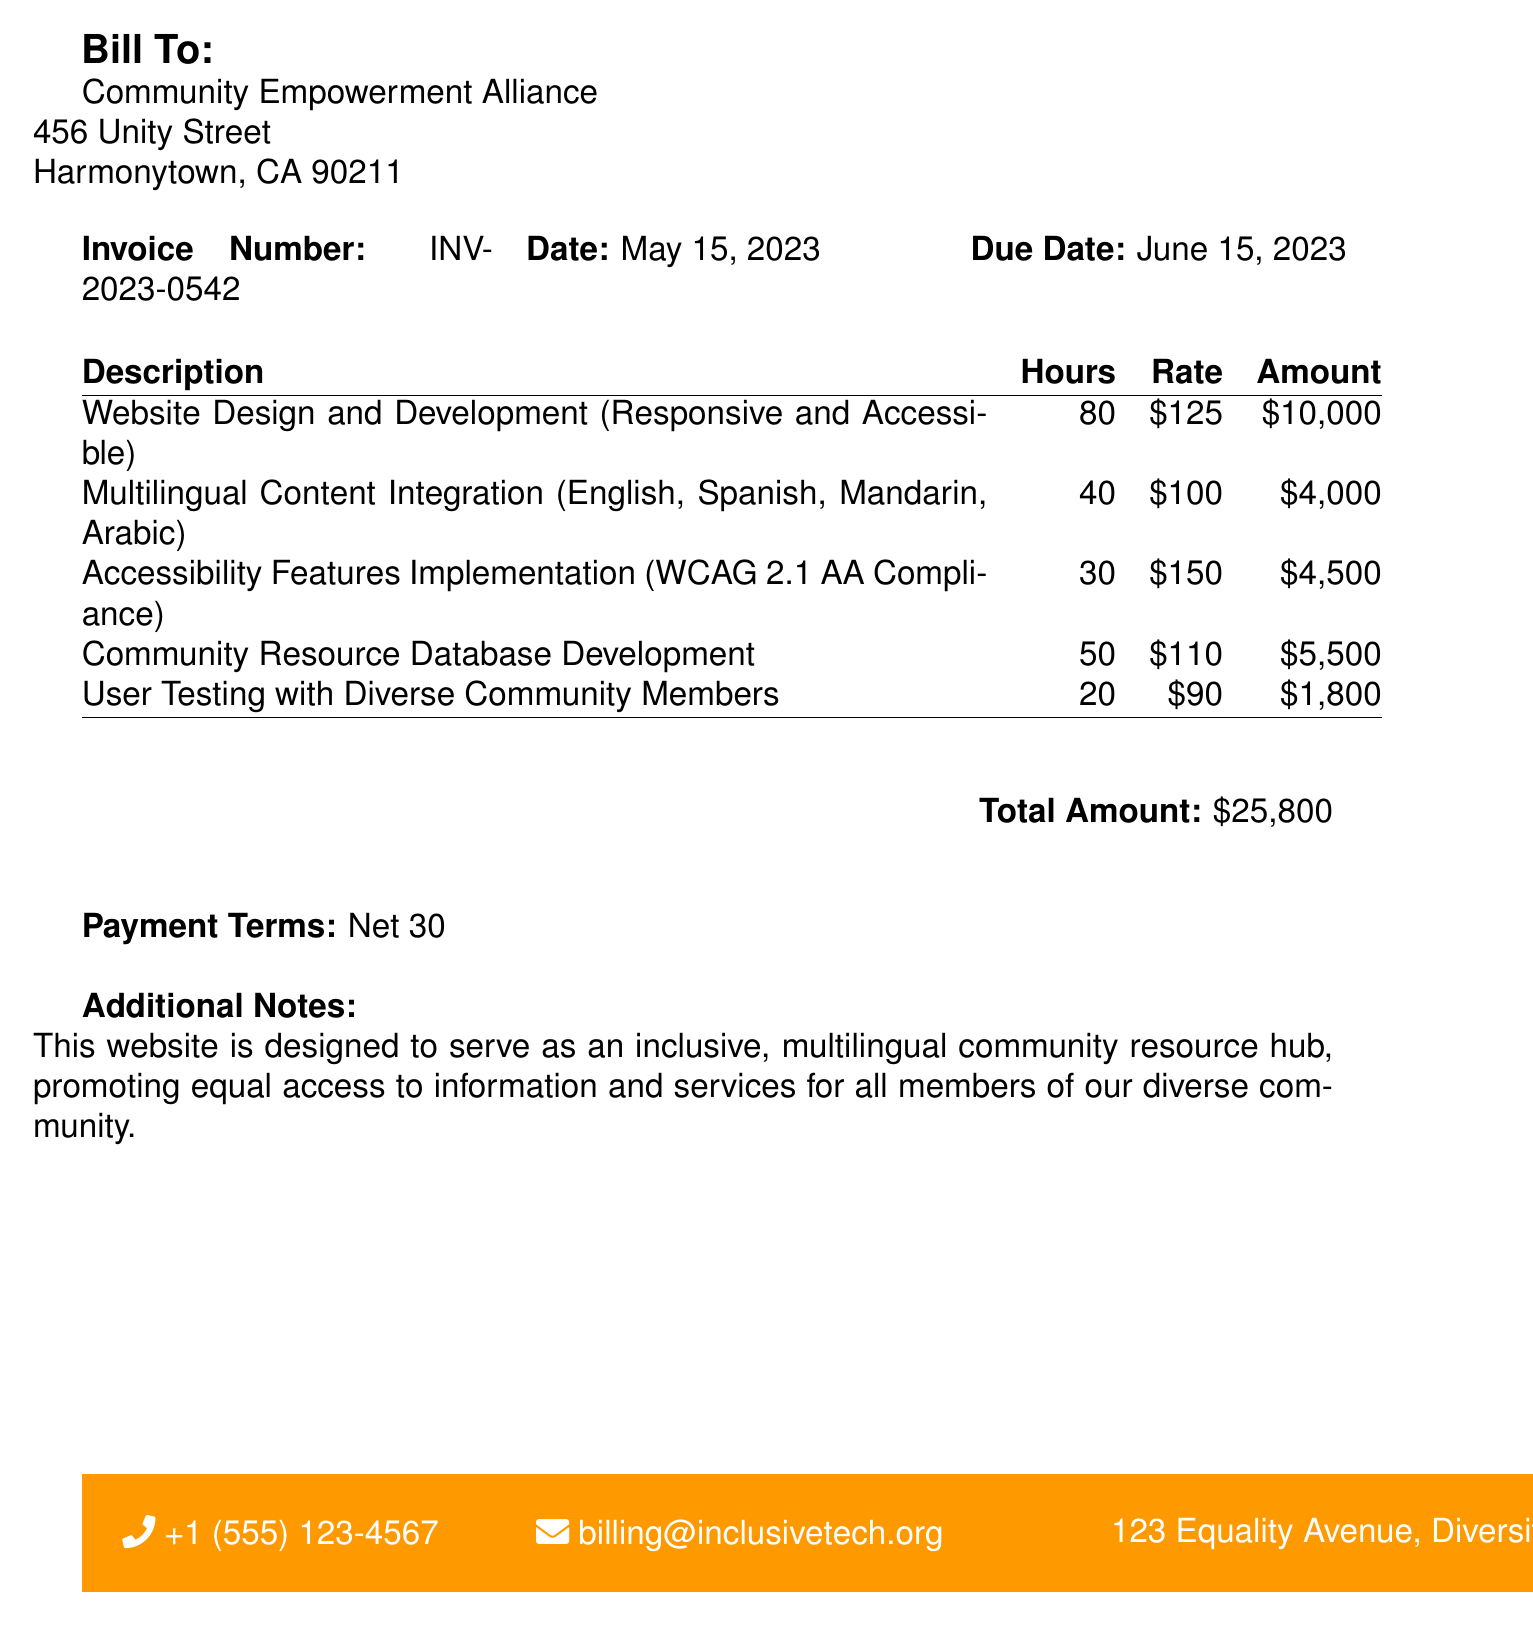what is the invoice number? The invoice number is stated clearly in the document under the invoice section.
Answer: INV-2023-0542 what is the due date for payment? The due date is listed in the invoice section and specifies when payment is required.
Answer: June 15, 2023 who is the bill addressed to? The document states the recipient of the bill within the introductory lines.
Answer: Community Empowerment Alliance how much is the total amount? The total amount is calculated and presented in the summary section of the document.
Answer: $25,800 how many hours were spent on website design and development? The number of hours for this task is specified in the detailed services section of the bill.
Answer: 80 what type of compliance is the accessibility features implementation aiming for? The document explicitly mentions the compliance standard that the accessibility features are designed to meet.
Answer: WCAG 2.1 AA what services were included in the multilingual content integration? The services provided are listed in the description section with specific languages mentioned.
Answer: English, Spanish, Mandarin, Arabic how many hours were allocated for user testing? This information is detailed in the table that breaks down hours for specific tasks.
Answer: 20 what is the rate for community resource database development? The rate for this specific service is included in the services breakdown of the document.
Answer: $110 